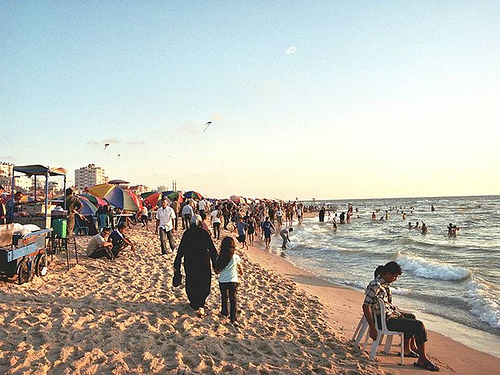Who is on the chair? A man is sitting alone on the chair by the beach, observing the surrounding activities. 